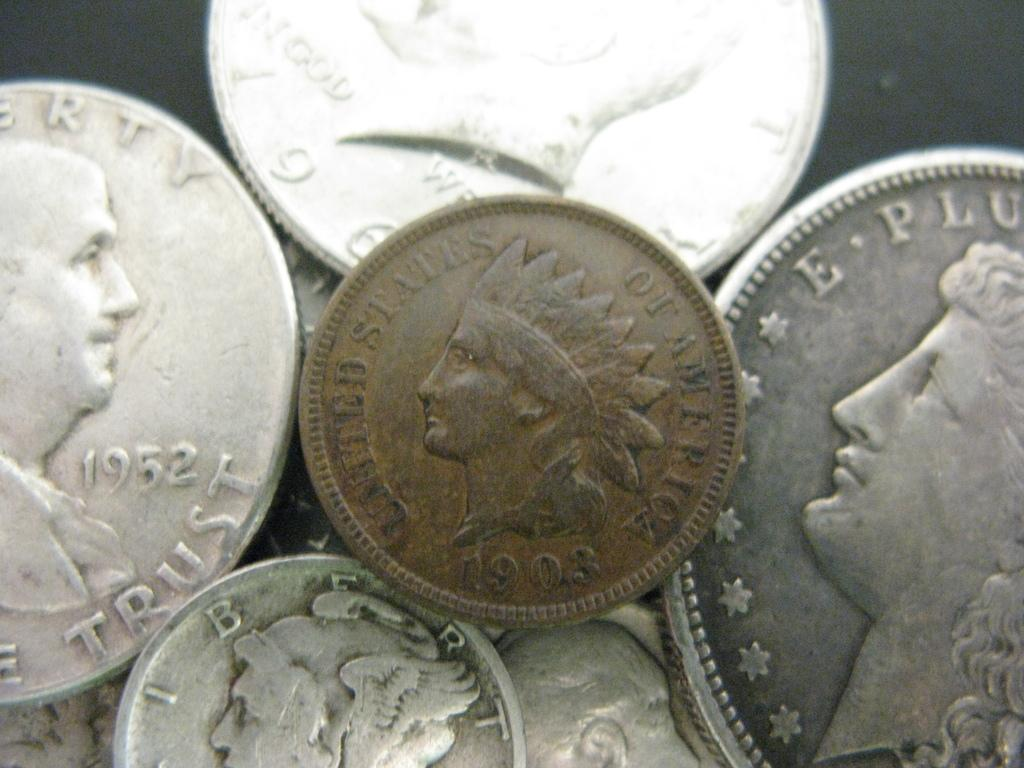<image>
Present a compact description of the photo's key features. A collection of silver colored coins and one bronze colored one from 1903. 